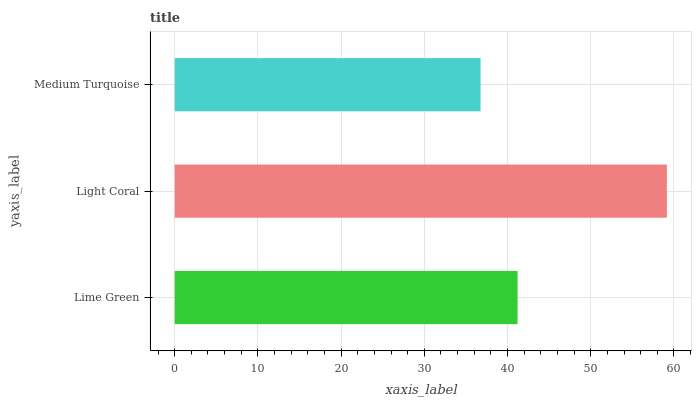Is Medium Turquoise the minimum?
Answer yes or no. Yes. Is Light Coral the maximum?
Answer yes or no. Yes. Is Light Coral the minimum?
Answer yes or no. No. Is Medium Turquoise the maximum?
Answer yes or no. No. Is Light Coral greater than Medium Turquoise?
Answer yes or no. Yes. Is Medium Turquoise less than Light Coral?
Answer yes or no. Yes. Is Medium Turquoise greater than Light Coral?
Answer yes or no. No. Is Light Coral less than Medium Turquoise?
Answer yes or no. No. Is Lime Green the high median?
Answer yes or no. Yes. Is Lime Green the low median?
Answer yes or no. Yes. Is Light Coral the high median?
Answer yes or no. No. Is Medium Turquoise the low median?
Answer yes or no. No. 